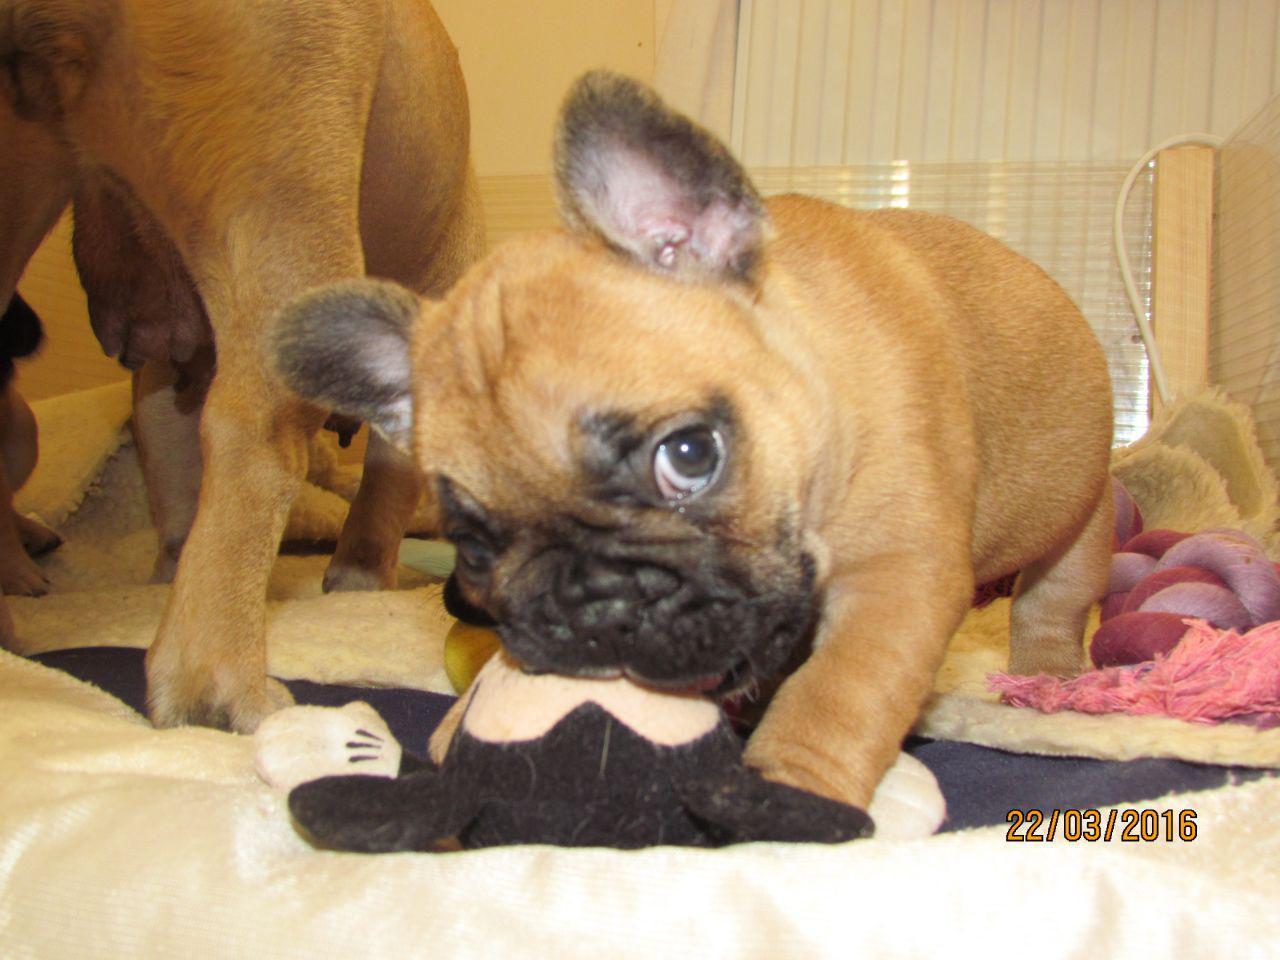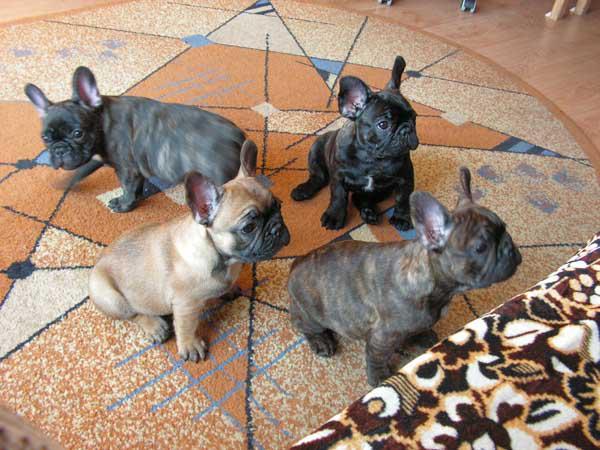The first image is the image on the left, the second image is the image on the right. For the images displayed, is the sentence "The dogs on the left are lined up." factually correct? Answer yes or no. No. The first image is the image on the left, the second image is the image on the right. For the images shown, is this caption "There are at least four animals in the image on the right." true? Answer yes or no. Yes. The first image is the image on the left, the second image is the image on the right. For the images displayed, is the sentence "There are no more than four dogs in the right image." factually correct? Answer yes or no. Yes. The first image is the image on the left, the second image is the image on the right. For the images displayed, is the sentence "One image contains more than 7 puppies." factually correct? Answer yes or no. No. 